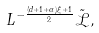<formula> <loc_0><loc_0><loc_500><loc_500>L ^ { - \frac { ( d + 1 + \alpha ) \xi + 1 } { 2 } } \tilde { \mathcal { L } } ,</formula> 